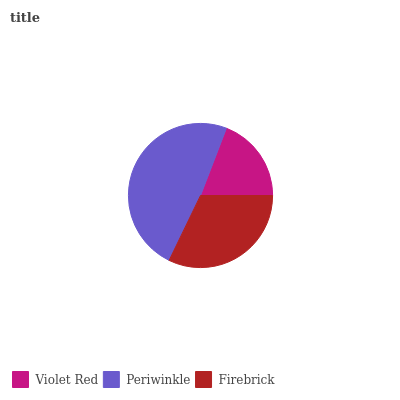Is Violet Red the minimum?
Answer yes or no. Yes. Is Periwinkle the maximum?
Answer yes or no. Yes. Is Firebrick the minimum?
Answer yes or no. No. Is Firebrick the maximum?
Answer yes or no. No. Is Periwinkle greater than Firebrick?
Answer yes or no. Yes. Is Firebrick less than Periwinkle?
Answer yes or no. Yes. Is Firebrick greater than Periwinkle?
Answer yes or no. No. Is Periwinkle less than Firebrick?
Answer yes or no. No. Is Firebrick the high median?
Answer yes or no. Yes. Is Firebrick the low median?
Answer yes or no. Yes. Is Periwinkle the high median?
Answer yes or no. No. Is Periwinkle the low median?
Answer yes or no. No. 